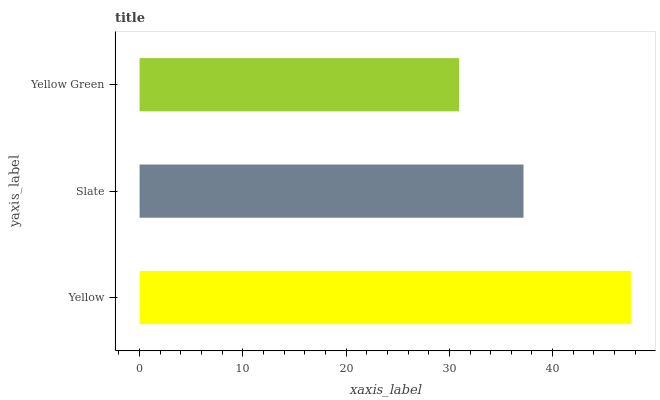Is Yellow Green the minimum?
Answer yes or no. Yes. Is Yellow the maximum?
Answer yes or no. Yes. Is Slate the minimum?
Answer yes or no. No. Is Slate the maximum?
Answer yes or no. No. Is Yellow greater than Slate?
Answer yes or no. Yes. Is Slate less than Yellow?
Answer yes or no. Yes. Is Slate greater than Yellow?
Answer yes or no. No. Is Yellow less than Slate?
Answer yes or no. No. Is Slate the high median?
Answer yes or no. Yes. Is Slate the low median?
Answer yes or no. Yes. Is Yellow the high median?
Answer yes or no. No. Is Yellow the low median?
Answer yes or no. No. 